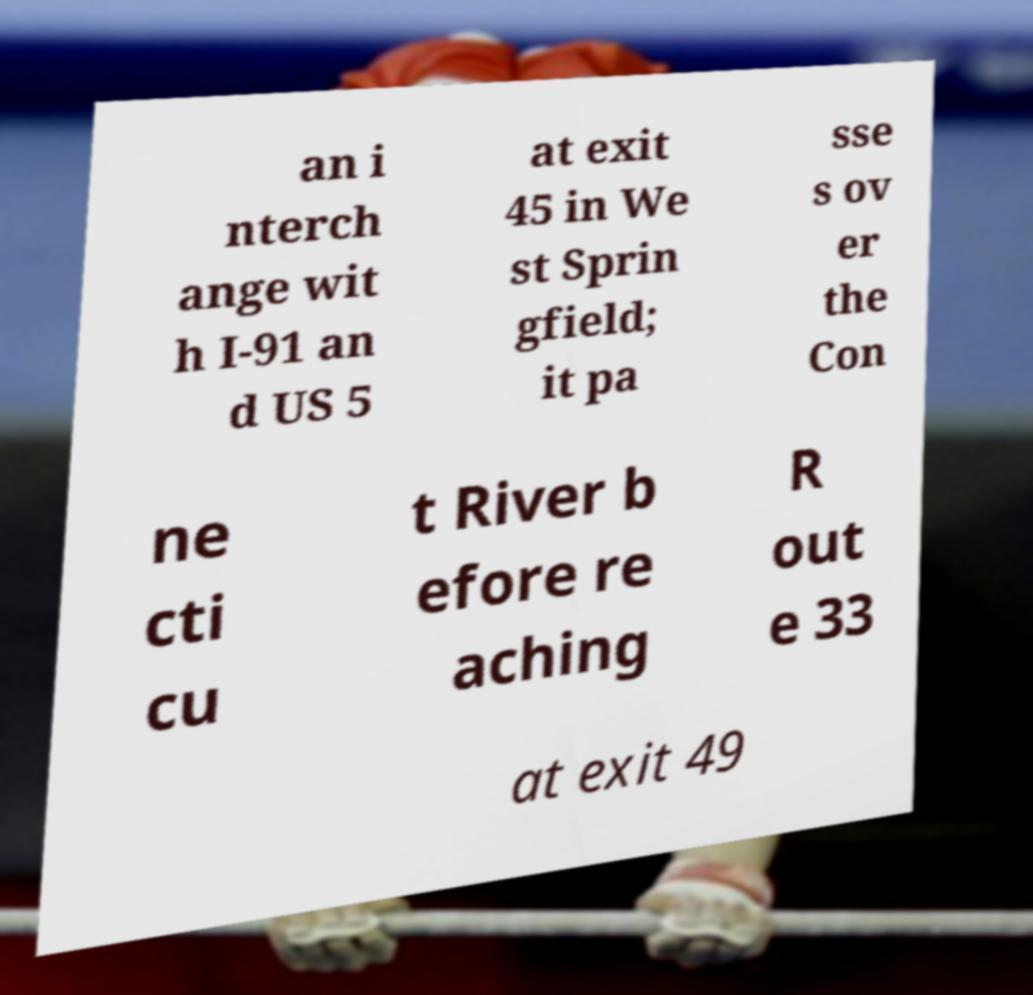For documentation purposes, I need the text within this image transcribed. Could you provide that? an i nterch ange wit h I-91 an d US 5 at exit 45 in We st Sprin gfield; it pa sse s ov er the Con ne cti cu t River b efore re aching R out e 33 at exit 49 